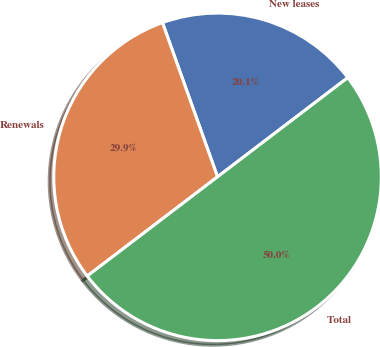Convert chart. <chart><loc_0><loc_0><loc_500><loc_500><pie_chart><fcel>New leases<fcel>Renewals<fcel>Total<nl><fcel>20.1%<fcel>29.9%<fcel>50.0%<nl></chart> 